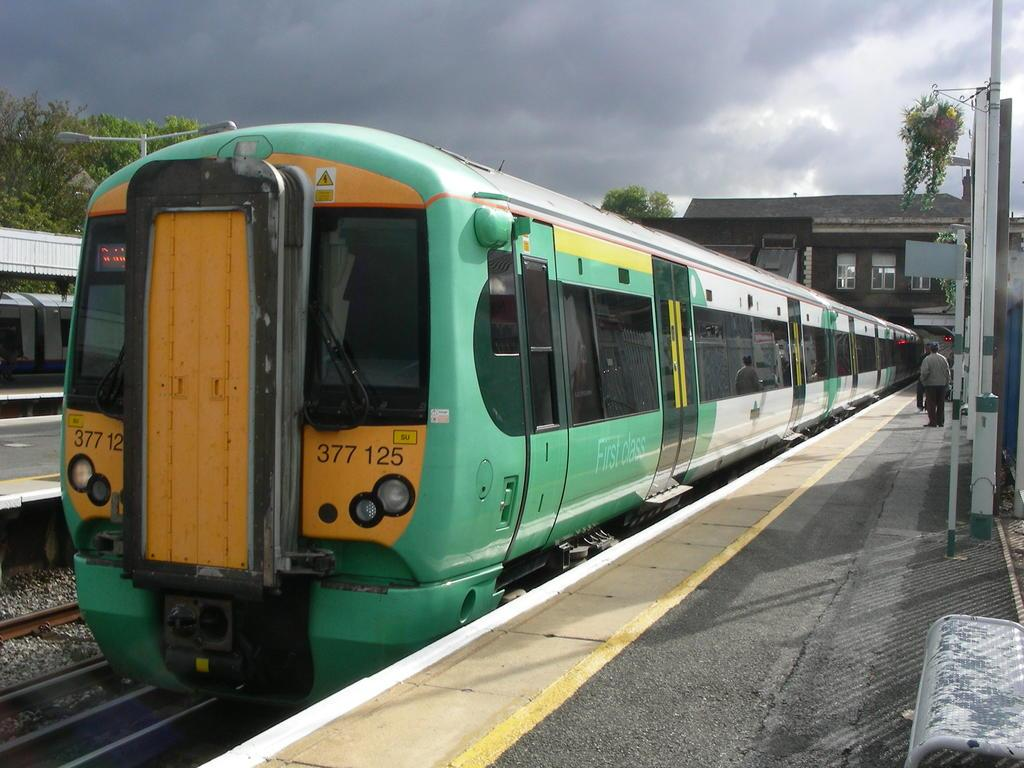Provide a one-sentence caption for the provided image. a train that has 377 written on it. 